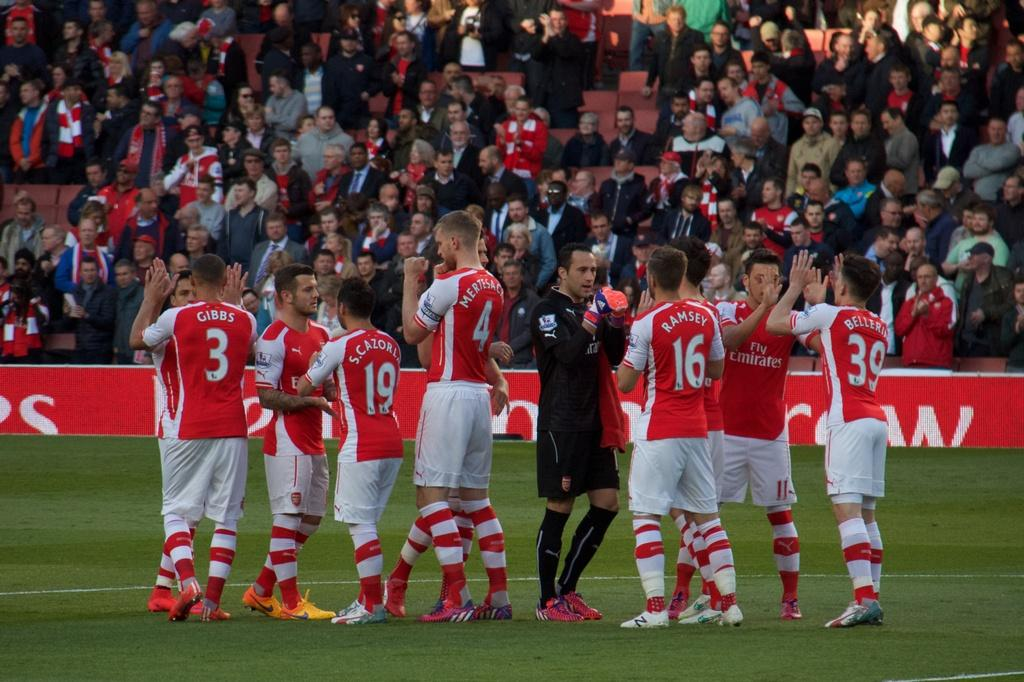<image>
Summarize the visual content of the image. Several athletes, including number 3 and 19, are celebrating on a field. 